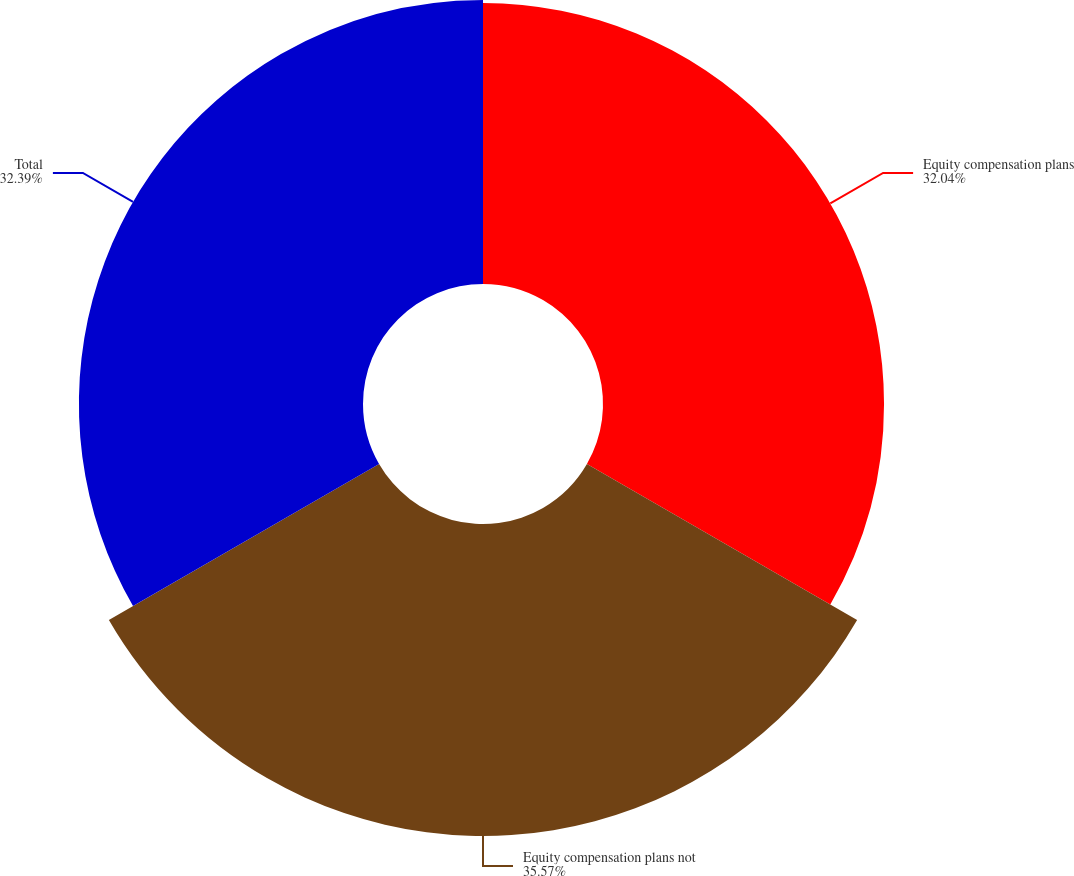<chart> <loc_0><loc_0><loc_500><loc_500><pie_chart><fcel>Equity compensation plans<fcel>Equity compensation plans not<fcel>Total<nl><fcel>32.04%<fcel>35.57%<fcel>32.39%<nl></chart> 